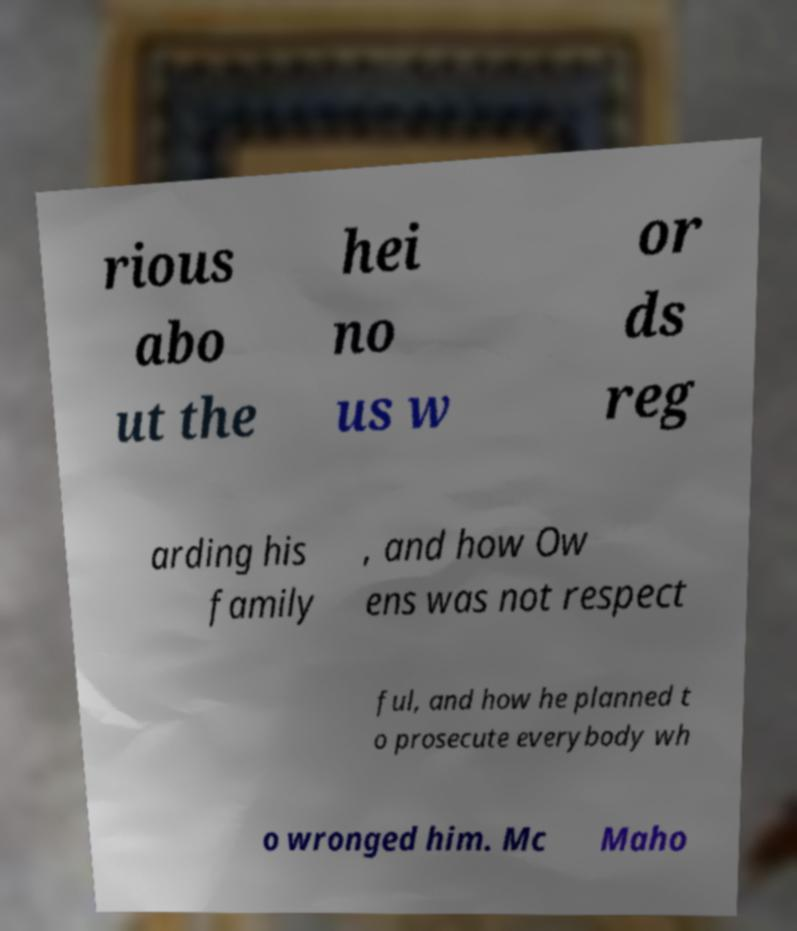Please identify and transcribe the text found in this image. rious abo ut the hei no us w or ds reg arding his family , and how Ow ens was not respect ful, and how he planned t o prosecute everybody wh o wronged him. Mc Maho 